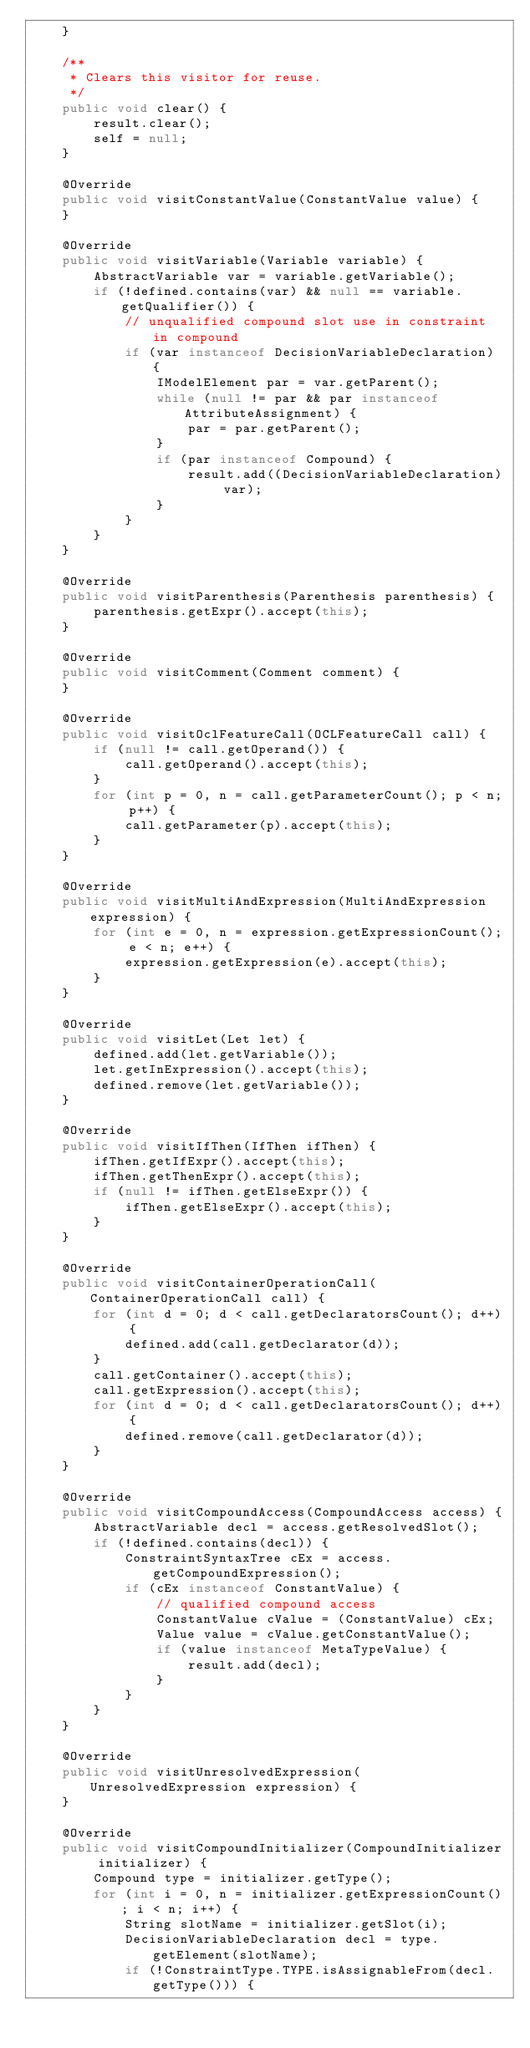<code> <loc_0><loc_0><loc_500><loc_500><_Java_>    }
    
    /**
     * Clears this visitor for reuse.
     */
    public void clear() {
        result.clear();
        self = null;
    }
    
    @Override
    public void visitConstantValue(ConstantValue value) {
    }

    @Override
    public void visitVariable(Variable variable) {
        AbstractVariable var = variable.getVariable();
        if (!defined.contains(var) && null == variable.getQualifier()) {
            // unqualified compound slot use in constraint in compound
            if (var instanceof DecisionVariableDeclaration) {
                IModelElement par = var.getParent();
                while (null != par && par instanceof AttributeAssignment) {
                    par = par.getParent();
                }
                if (par instanceof Compound) {
                    result.add((DecisionVariableDeclaration) var);
                }
            }
        }
    }

    @Override
    public void visitParenthesis(Parenthesis parenthesis) {
        parenthesis.getExpr().accept(this);
    }

    @Override
    public void visitComment(Comment comment) {
    }

    @Override
    public void visitOclFeatureCall(OCLFeatureCall call) {
        if (null != call.getOperand()) {
            call.getOperand().accept(this);
        }
        for (int p = 0, n = call.getParameterCount(); p < n; p++) {
            call.getParameter(p).accept(this);
        }
    }

    @Override
    public void visitMultiAndExpression(MultiAndExpression expression) {
        for (int e = 0, n = expression.getExpressionCount(); e < n; e++) {
            expression.getExpression(e).accept(this);
        }
    }

    @Override
    public void visitLet(Let let) {
        defined.add(let.getVariable());
        let.getInExpression().accept(this);
        defined.remove(let.getVariable());
    }

    @Override
    public void visitIfThen(IfThen ifThen) {
        ifThen.getIfExpr().accept(this);
        ifThen.getThenExpr().accept(this);
        if (null != ifThen.getElseExpr()) {
            ifThen.getElseExpr().accept(this);
        }
    }

    @Override
    public void visitContainerOperationCall(ContainerOperationCall call) {
        for (int d = 0; d < call.getDeclaratorsCount(); d++) {
            defined.add(call.getDeclarator(d));
        }
        call.getContainer().accept(this);
        call.getExpression().accept(this);
        for (int d = 0; d < call.getDeclaratorsCount(); d++) {
            defined.remove(call.getDeclarator(d));
        }   
    }

    @Override
    public void visitCompoundAccess(CompoundAccess access) {
        AbstractVariable decl = access.getResolvedSlot();
        if (!defined.contains(decl)) {
            ConstraintSyntaxTree cEx = access.getCompoundExpression();
            if (cEx instanceof ConstantValue) {
                // qualified compound access
                ConstantValue cValue = (ConstantValue) cEx;
                Value value = cValue.getConstantValue();
                if (value instanceof MetaTypeValue) {
                    result.add(decl);
                }
            }
        }
    }

    @Override
    public void visitUnresolvedExpression(UnresolvedExpression expression) {
    }

    @Override
    public void visitCompoundInitializer(CompoundInitializer initializer) {
        Compound type = initializer.getType();
        for (int i = 0, n = initializer.getExpressionCount(); i < n; i++) {
            String slotName = initializer.getSlot(i);
            DecisionVariableDeclaration decl = type.getElement(slotName);
            if (!ConstraintType.TYPE.isAssignableFrom(decl.getType())) {</code> 